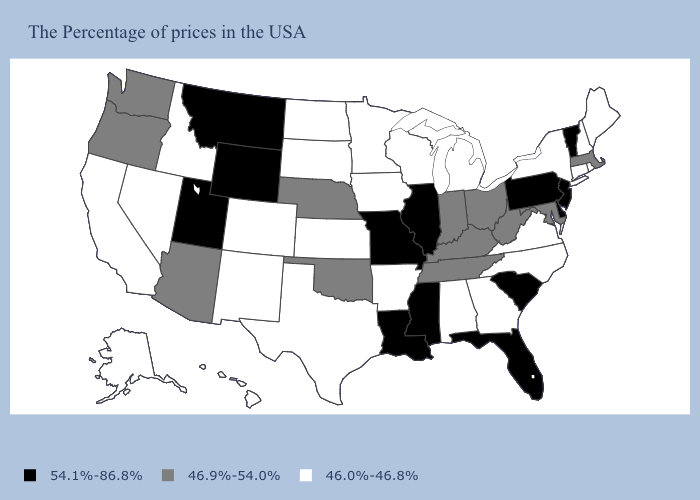How many symbols are there in the legend?
Give a very brief answer. 3. Does the first symbol in the legend represent the smallest category?
Short answer required. No. Does Louisiana have the highest value in the South?
Give a very brief answer. Yes. Does Pennsylvania have the highest value in the USA?
Write a very short answer. Yes. Does Colorado have the lowest value in the West?
Short answer required. Yes. How many symbols are there in the legend?
Keep it brief. 3. How many symbols are there in the legend?
Keep it brief. 3. Among the states that border Iowa , does Illinois have the highest value?
Be succinct. Yes. What is the lowest value in the Northeast?
Quick response, please. 46.0%-46.8%. Does the first symbol in the legend represent the smallest category?
Answer briefly. No. Does Oklahoma have the same value as Massachusetts?
Quick response, please. Yes. Name the states that have a value in the range 46.9%-54.0%?
Be succinct. Massachusetts, Maryland, West Virginia, Ohio, Kentucky, Indiana, Tennessee, Nebraska, Oklahoma, Arizona, Washington, Oregon. Does South Carolina have the lowest value in the South?
Quick response, please. No. Does Missouri have the highest value in the USA?
Concise answer only. Yes. 